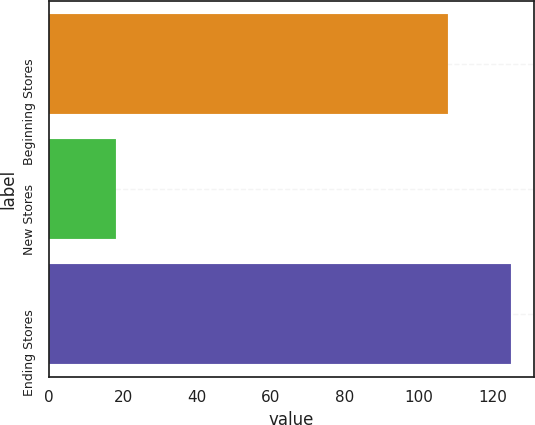Convert chart to OTSL. <chart><loc_0><loc_0><loc_500><loc_500><bar_chart><fcel>Beginning Stores<fcel>New Stores<fcel>Ending Stores<nl><fcel>108<fcel>18<fcel>125<nl></chart> 